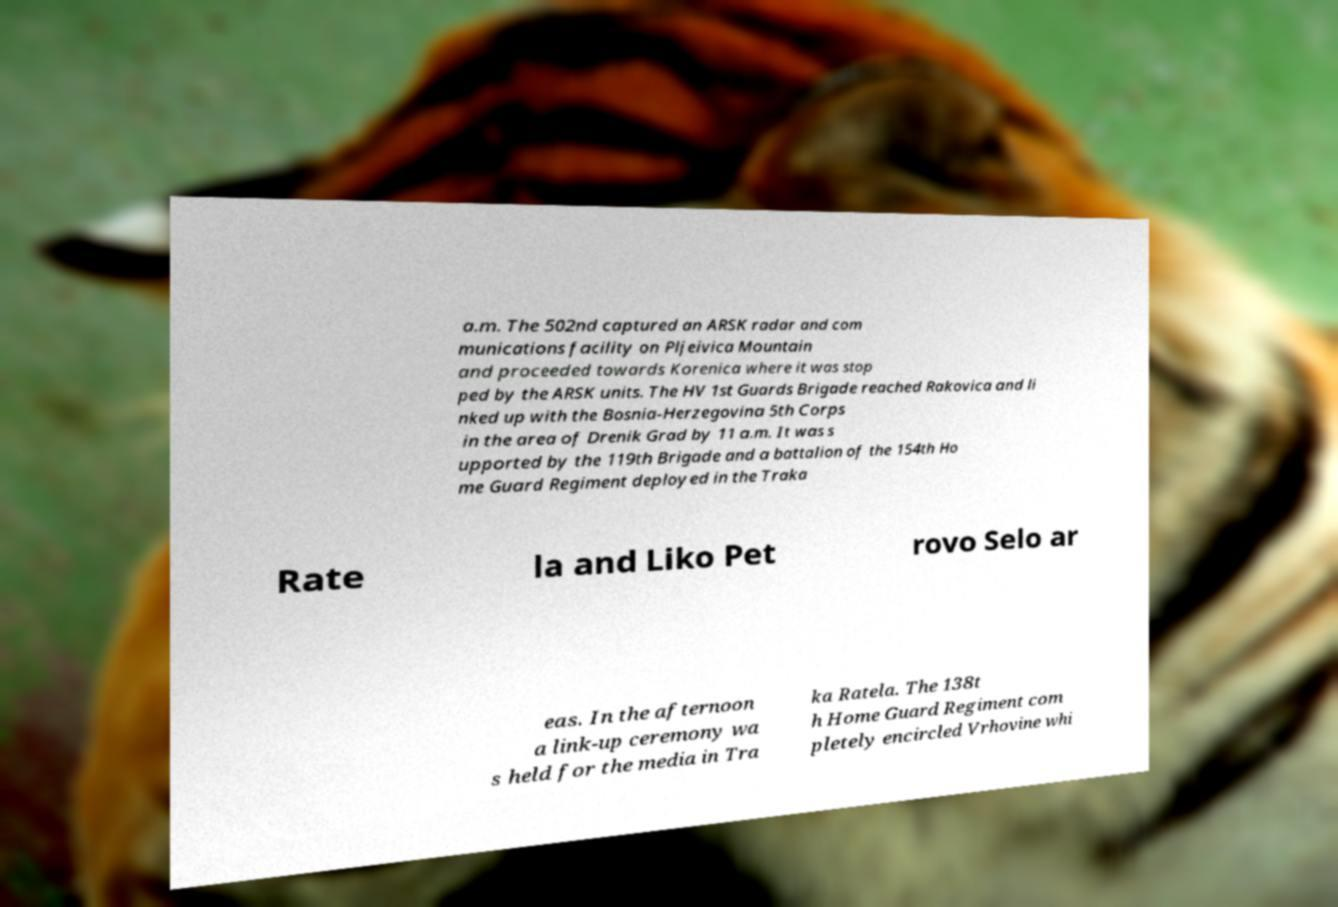Please identify and transcribe the text found in this image. a.m. The 502nd captured an ARSK radar and com munications facility on Pljeivica Mountain and proceeded towards Korenica where it was stop ped by the ARSK units. The HV 1st Guards Brigade reached Rakovica and li nked up with the Bosnia-Herzegovina 5th Corps in the area of Drenik Grad by 11 a.m. It was s upported by the 119th Brigade and a battalion of the 154th Ho me Guard Regiment deployed in the Traka Rate la and Liko Pet rovo Selo ar eas. In the afternoon a link-up ceremony wa s held for the media in Tra ka Ratela. The 138t h Home Guard Regiment com pletely encircled Vrhovine whi 